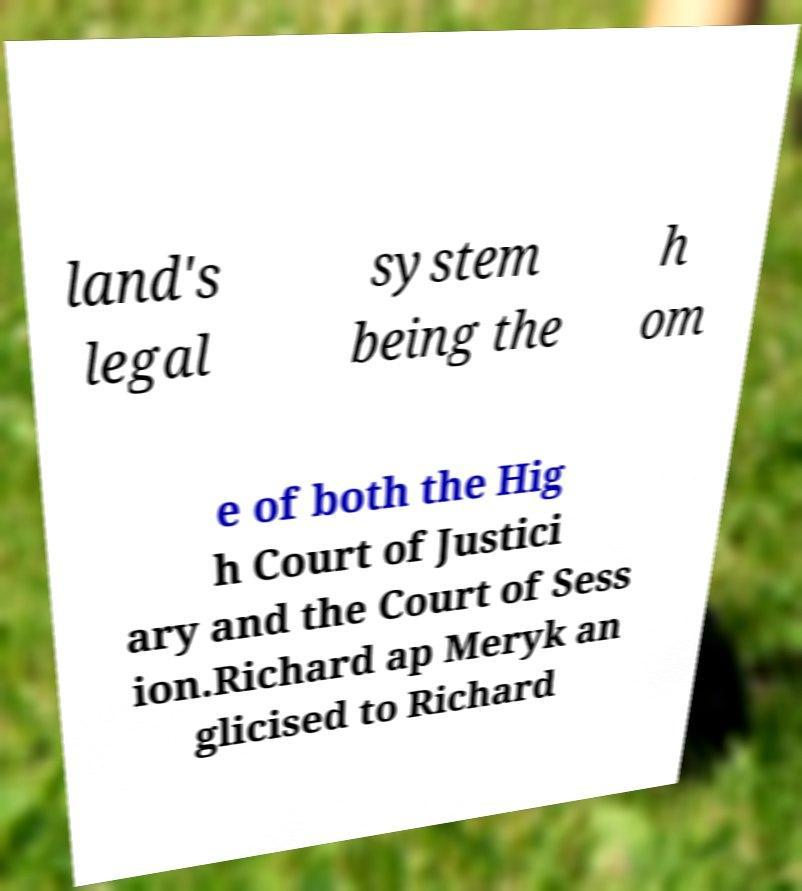Please read and relay the text visible in this image. What does it say? land's legal system being the h om e of both the Hig h Court of Justici ary and the Court of Sess ion.Richard ap Meryk an glicised to Richard 